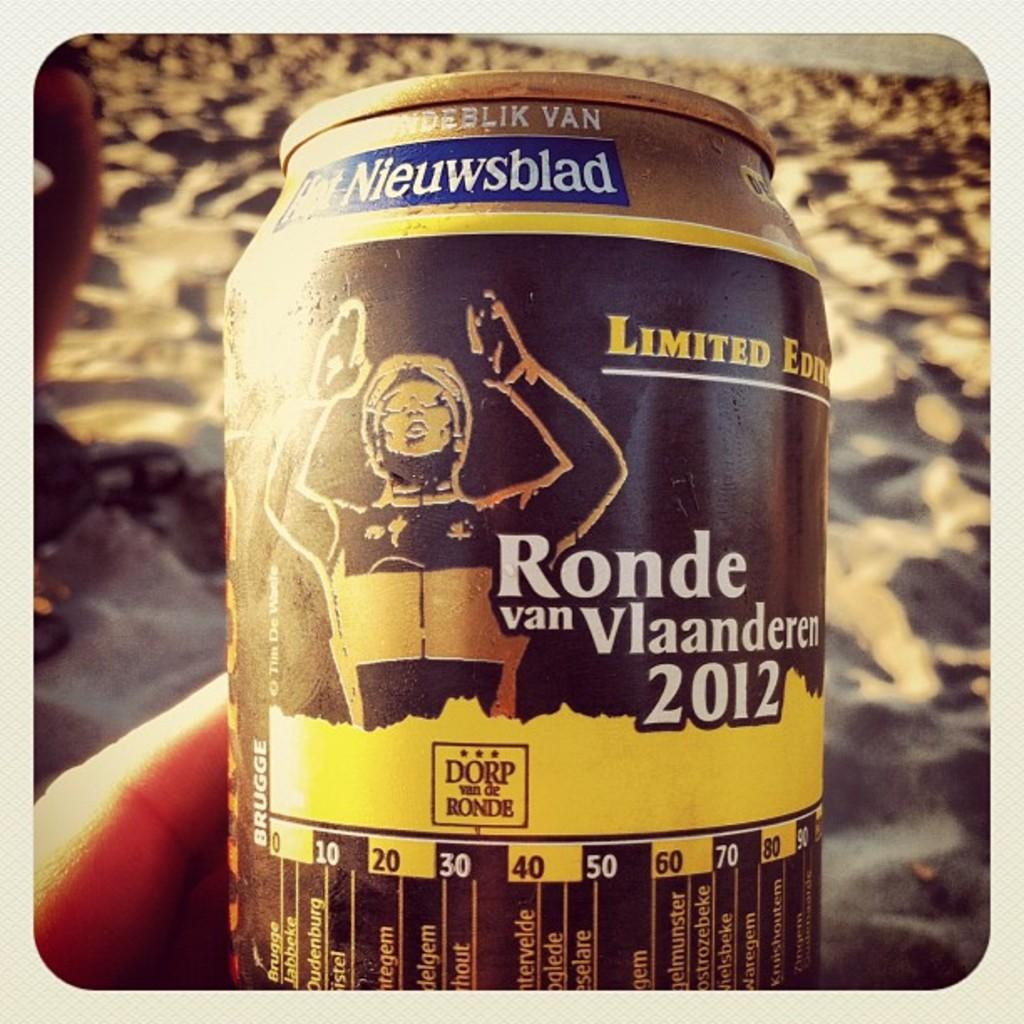Provide a one-sentence caption for the provided image. A can shows Ronde van Vlaanderen on it. 